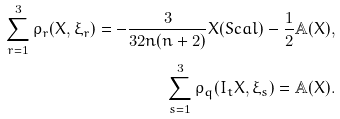Convert formula to latex. <formula><loc_0><loc_0><loc_500><loc_500>\sum _ { r = 1 } ^ { 3 } \rho _ { r } ( X , \xi _ { r } ) = - \frac { 3 } { 3 2 n ( n + 2 ) } X ( S c a l ) - \frac { 1 } { 2 } \mathbb { A } ( X ) , \\ \sum _ { s = 1 } ^ { 3 } \rho _ { q } ( I _ { t } X , \xi _ { s } ) = \mathbb { A } ( X ) .</formula> 